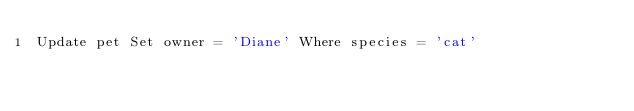Convert code to text. <code><loc_0><loc_0><loc_500><loc_500><_SQL_>Update pet Set owner = 'Diane' Where species = 'cat'</code> 